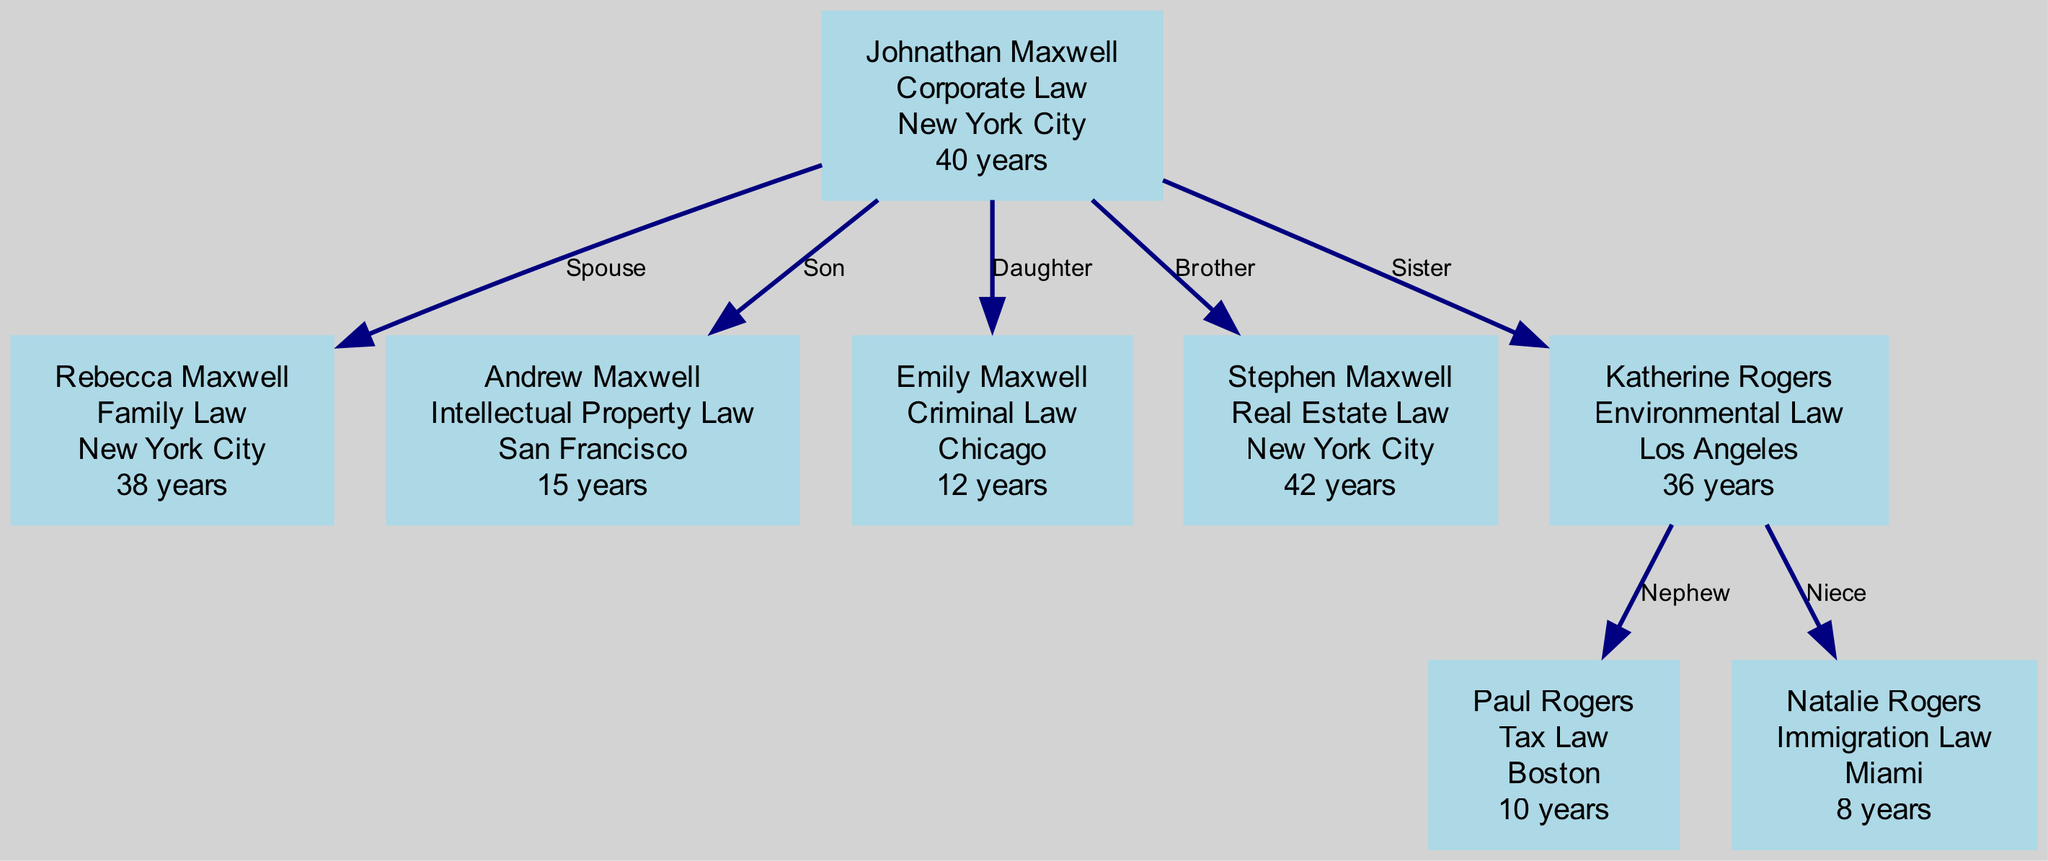What is Johnathan Maxwell's specialization? According to the diagram, each member has a specialization listed. For Johnathan Maxwell, it is specified as "Corporate Law."
Answer: Corporate Law How many years of experience does Rebecca Maxwell have? The information in the diagram shows that Rebecca Maxwell has "38 years" of experience stated next to her name.
Answer: 38 years What is the location of Andrew Maxwell? The diagram indicates that Andrew Maxwell is located in "San Francisco," which is listed alongside his name.
Answer: San Francisco Who is Stephen Maxwell's relation to Johnathan Maxwell? In the diagram, it shows that Stephen Maxwell is labeled as "Brother" to Johnathan Maxwell, indicating that they share a sibling relationship.
Answer: Brother How many members specialize in law related to real estate? The diagram outlines several family members and their specializations. Only one member, Stephen Maxwell, specializes in "Real Estate Law," thus the count is one.
Answer: 1 What are the specializations of Johnathan and Rebecca Maxwell combined? By examining the diagram, Johnathan specializes in "Corporate Law" and Rebecca in "Family Law." Together, their specializations are "Corporate Law" and "Family Law."
Answer: Corporate Law, Family Law Which member has the least years of experience? The years of experience for the members can be found in the diagram. Natalie Rogers has "8 years," which is the lowest among all listed members.
Answer: 8 years How many children do Johnathan and Rebecca Maxwell have? The diagram indicates that Johnathan and Rebecca have two children: Andrew and Emily. Therefore, by counting the members identified as their children, the total is two.
Answer: 2 What specialization does Natalie Rogers have in relation to her location? The diagram connects Natalie Rogers to "Immigration Law," and explicitly states her location as "Miami," providing a direct link between her specialization and location.
Answer: Immigration Law 